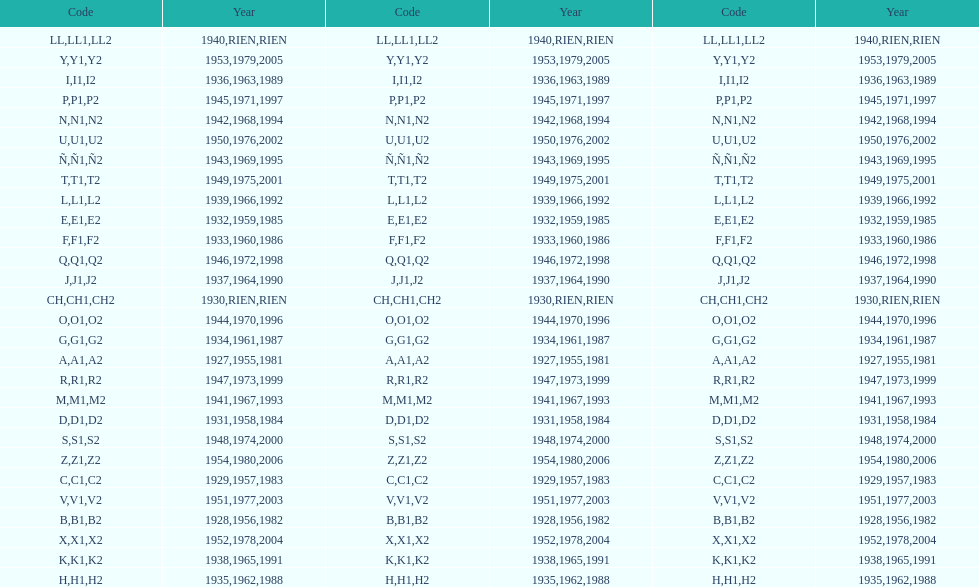What was the lowest year stamped? 1927. 